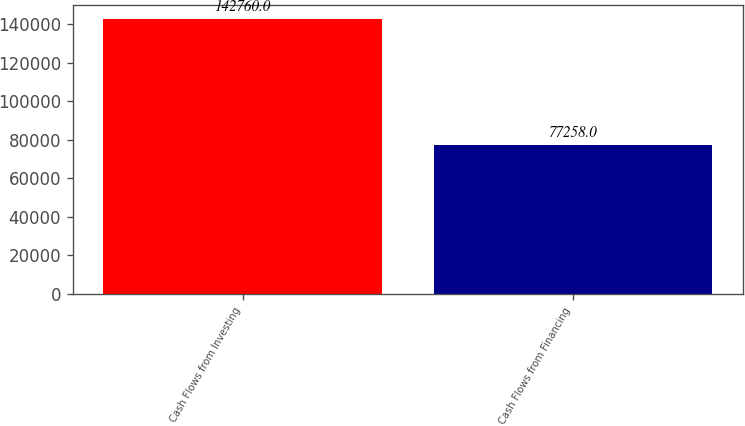Convert chart to OTSL. <chart><loc_0><loc_0><loc_500><loc_500><bar_chart><fcel>Cash Flows from Investing<fcel>Cash Flows from Financing<nl><fcel>142760<fcel>77258<nl></chart> 